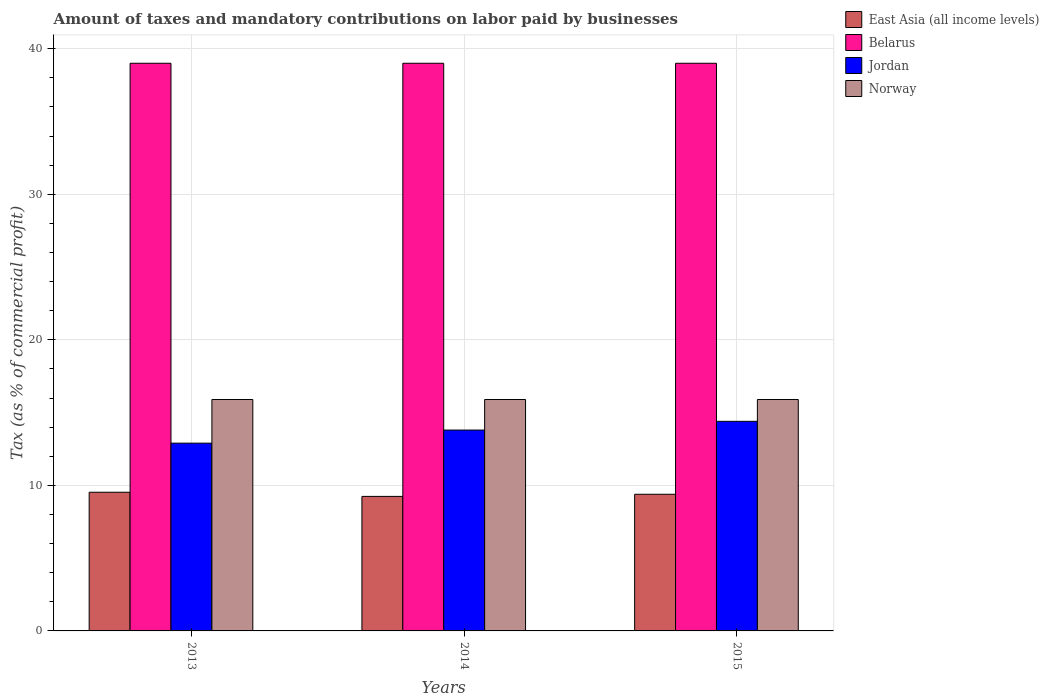How many different coloured bars are there?
Keep it short and to the point. 4. How many groups of bars are there?
Keep it short and to the point. 3. Are the number of bars per tick equal to the number of legend labels?
Provide a short and direct response. Yes. Are the number of bars on each tick of the X-axis equal?
Your answer should be compact. Yes. How many bars are there on the 1st tick from the right?
Give a very brief answer. 4. In how many cases, is the number of bars for a given year not equal to the number of legend labels?
Your response must be concise. 0. What is the percentage of taxes paid by businesses in East Asia (all income levels) in 2014?
Give a very brief answer. 9.24. Across all years, what is the minimum percentage of taxes paid by businesses in Norway?
Offer a very short reply. 15.9. In which year was the percentage of taxes paid by businesses in East Asia (all income levels) maximum?
Your answer should be compact. 2013. What is the total percentage of taxes paid by businesses in Norway in the graph?
Provide a succinct answer. 47.7. What is the difference between the percentage of taxes paid by businesses in East Asia (all income levels) in 2014 and that in 2015?
Your answer should be compact. -0.15. What is the difference between the percentage of taxes paid by businesses in Norway in 2015 and the percentage of taxes paid by businesses in Belarus in 2013?
Give a very brief answer. -23.1. What is the average percentage of taxes paid by businesses in Belarus per year?
Provide a succinct answer. 39. In the year 2014, what is the difference between the percentage of taxes paid by businesses in Norway and percentage of taxes paid by businesses in Jordan?
Your answer should be very brief. 2.1. In how many years, is the percentage of taxes paid by businesses in East Asia (all income levels) greater than 34 %?
Make the answer very short. 0. Is the percentage of taxes paid by businesses in East Asia (all income levels) in 2013 less than that in 2015?
Offer a terse response. No. Is the difference between the percentage of taxes paid by businesses in Norway in 2014 and 2015 greater than the difference between the percentage of taxes paid by businesses in Jordan in 2014 and 2015?
Your answer should be compact. Yes. What is the difference between the highest and the lowest percentage of taxes paid by businesses in East Asia (all income levels)?
Give a very brief answer. 0.29. In how many years, is the percentage of taxes paid by businesses in Belarus greater than the average percentage of taxes paid by businesses in Belarus taken over all years?
Your answer should be very brief. 0. Is the sum of the percentage of taxes paid by businesses in Norway in 2013 and 2015 greater than the maximum percentage of taxes paid by businesses in Jordan across all years?
Your answer should be very brief. Yes. Is it the case that in every year, the sum of the percentage of taxes paid by businesses in Norway and percentage of taxes paid by businesses in Jordan is greater than the sum of percentage of taxes paid by businesses in Belarus and percentage of taxes paid by businesses in East Asia (all income levels)?
Your answer should be compact. Yes. What does the 3rd bar from the left in 2013 represents?
Keep it short and to the point. Jordan. What does the 2nd bar from the right in 2014 represents?
Make the answer very short. Jordan. Is it the case that in every year, the sum of the percentage of taxes paid by businesses in Belarus and percentage of taxes paid by businesses in Jordan is greater than the percentage of taxes paid by businesses in East Asia (all income levels)?
Give a very brief answer. Yes. How many bars are there?
Make the answer very short. 12. How many years are there in the graph?
Offer a very short reply. 3. What is the difference between two consecutive major ticks on the Y-axis?
Provide a succinct answer. 10. Are the values on the major ticks of Y-axis written in scientific E-notation?
Ensure brevity in your answer.  No. Does the graph contain any zero values?
Offer a very short reply. No. Does the graph contain grids?
Provide a short and direct response. Yes. Where does the legend appear in the graph?
Provide a short and direct response. Top right. How many legend labels are there?
Ensure brevity in your answer.  4. What is the title of the graph?
Your response must be concise. Amount of taxes and mandatory contributions on labor paid by businesses. What is the label or title of the Y-axis?
Make the answer very short. Tax (as % of commercial profit). What is the Tax (as % of commercial profit) of East Asia (all income levels) in 2013?
Ensure brevity in your answer.  9.53. What is the Tax (as % of commercial profit) in East Asia (all income levels) in 2014?
Your response must be concise. 9.24. What is the Tax (as % of commercial profit) of Belarus in 2014?
Your answer should be very brief. 39. What is the Tax (as % of commercial profit) in Jordan in 2014?
Ensure brevity in your answer.  13.8. What is the Tax (as % of commercial profit) in East Asia (all income levels) in 2015?
Offer a very short reply. 9.39. What is the Tax (as % of commercial profit) in Belarus in 2015?
Your answer should be very brief. 39. What is the Tax (as % of commercial profit) of Jordan in 2015?
Your answer should be very brief. 14.4. What is the Tax (as % of commercial profit) in Norway in 2015?
Your response must be concise. 15.9. Across all years, what is the maximum Tax (as % of commercial profit) of East Asia (all income levels)?
Your answer should be very brief. 9.53. Across all years, what is the maximum Tax (as % of commercial profit) of Jordan?
Give a very brief answer. 14.4. Across all years, what is the minimum Tax (as % of commercial profit) in East Asia (all income levels)?
Provide a succinct answer. 9.24. Across all years, what is the minimum Tax (as % of commercial profit) in Jordan?
Your answer should be compact. 12.9. Across all years, what is the minimum Tax (as % of commercial profit) of Norway?
Give a very brief answer. 15.9. What is the total Tax (as % of commercial profit) in East Asia (all income levels) in the graph?
Offer a very short reply. 28.16. What is the total Tax (as % of commercial profit) in Belarus in the graph?
Offer a very short reply. 117. What is the total Tax (as % of commercial profit) of Jordan in the graph?
Give a very brief answer. 41.1. What is the total Tax (as % of commercial profit) in Norway in the graph?
Make the answer very short. 47.7. What is the difference between the Tax (as % of commercial profit) in East Asia (all income levels) in 2013 and that in 2014?
Your answer should be compact. 0.29. What is the difference between the Tax (as % of commercial profit) of Belarus in 2013 and that in 2014?
Offer a very short reply. 0. What is the difference between the Tax (as % of commercial profit) in Jordan in 2013 and that in 2014?
Your answer should be very brief. -0.9. What is the difference between the Tax (as % of commercial profit) of East Asia (all income levels) in 2013 and that in 2015?
Your response must be concise. 0.14. What is the difference between the Tax (as % of commercial profit) of Belarus in 2013 and that in 2015?
Provide a succinct answer. 0. What is the difference between the Tax (as % of commercial profit) of East Asia (all income levels) in 2014 and that in 2015?
Ensure brevity in your answer.  -0.15. What is the difference between the Tax (as % of commercial profit) of Belarus in 2014 and that in 2015?
Provide a succinct answer. 0. What is the difference between the Tax (as % of commercial profit) of Jordan in 2014 and that in 2015?
Offer a terse response. -0.6. What is the difference between the Tax (as % of commercial profit) in Norway in 2014 and that in 2015?
Offer a terse response. 0. What is the difference between the Tax (as % of commercial profit) of East Asia (all income levels) in 2013 and the Tax (as % of commercial profit) of Belarus in 2014?
Provide a short and direct response. -29.47. What is the difference between the Tax (as % of commercial profit) of East Asia (all income levels) in 2013 and the Tax (as % of commercial profit) of Jordan in 2014?
Ensure brevity in your answer.  -4.27. What is the difference between the Tax (as % of commercial profit) in East Asia (all income levels) in 2013 and the Tax (as % of commercial profit) in Norway in 2014?
Offer a very short reply. -6.37. What is the difference between the Tax (as % of commercial profit) of Belarus in 2013 and the Tax (as % of commercial profit) of Jordan in 2014?
Your answer should be very brief. 25.2. What is the difference between the Tax (as % of commercial profit) of Belarus in 2013 and the Tax (as % of commercial profit) of Norway in 2014?
Offer a terse response. 23.1. What is the difference between the Tax (as % of commercial profit) of Jordan in 2013 and the Tax (as % of commercial profit) of Norway in 2014?
Make the answer very short. -3. What is the difference between the Tax (as % of commercial profit) in East Asia (all income levels) in 2013 and the Tax (as % of commercial profit) in Belarus in 2015?
Give a very brief answer. -29.47. What is the difference between the Tax (as % of commercial profit) in East Asia (all income levels) in 2013 and the Tax (as % of commercial profit) in Jordan in 2015?
Keep it short and to the point. -4.87. What is the difference between the Tax (as % of commercial profit) in East Asia (all income levels) in 2013 and the Tax (as % of commercial profit) in Norway in 2015?
Give a very brief answer. -6.37. What is the difference between the Tax (as % of commercial profit) of Belarus in 2013 and the Tax (as % of commercial profit) of Jordan in 2015?
Offer a terse response. 24.6. What is the difference between the Tax (as % of commercial profit) in Belarus in 2013 and the Tax (as % of commercial profit) in Norway in 2015?
Make the answer very short. 23.1. What is the difference between the Tax (as % of commercial profit) in Jordan in 2013 and the Tax (as % of commercial profit) in Norway in 2015?
Offer a very short reply. -3. What is the difference between the Tax (as % of commercial profit) of East Asia (all income levels) in 2014 and the Tax (as % of commercial profit) of Belarus in 2015?
Provide a succinct answer. -29.76. What is the difference between the Tax (as % of commercial profit) in East Asia (all income levels) in 2014 and the Tax (as % of commercial profit) in Jordan in 2015?
Your answer should be compact. -5.16. What is the difference between the Tax (as % of commercial profit) in East Asia (all income levels) in 2014 and the Tax (as % of commercial profit) in Norway in 2015?
Ensure brevity in your answer.  -6.66. What is the difference between the Tax (as % of commercial profit) in Belarus in 2014 and the Tax (as % of commercial profit) in Jordan in 2015?
Offer a very short reply. 24.6. What is the difference between the Tax (as % of commercial profit) in Belarus in 2014 and the Tax (as % of commercial profit) in Norway in 2015?
Your response must be concise. 23.1. What is the difference between the Tax (as % of commercial profit) in Jordan in 2014 and the Tax (as % of commercial profit) in Norway in 2015?
Keep it short and to the point. -2.1. What is the average Tax (as % of commercial profit) in East Asia (all income levels) per year?
Give a very brief answer. 9.39. What is the average Tax (as % of commercial profit) of Belarus per year?
Give a very brief answer. 39. What is the average Tax (as % of commercial profit) of Jordan per year?
Offer a terse response. 13.7. In the year 2013, what is the difference between the Tax (as % of commercial profit) in East Asia (all income levels) and Tax (as % of commercial profit) in Belarus?
Your answer should be very brief. -29.47. In the year 2013, what is the difference between the Tax (as % of commercial profit) in East Asia (all income levels) and Tax (as % of commercial profit) in Jordan?
Offer a very short reply. -3.37. In the year 2013, what is the difference between the Tax (as % of commercial profit) of East Asia (all income levels) and Tax (as % of commercial profit) of Norway?
Make the answer very short. -6.37. In the year 2013, what is the difference between the Tax (as % of commercial profit) in Belarus and Tax (as % of commercial profit) in Jordan?
Give a very brief answer. 26.1. In the year 2013, what is the difference between the Tax (as % of commercial profit) in Belarus and Tax (as % of commercial profit) in Norway?
Provide a short and direct response. 23.1. In the year 2013, what is the difference between the Tax (as % of commercial profit) in Jordan and Tax (as % of commercial profit) in Norway?
Ensure brevity in your answer.  -3. In the year 2014, what is the difference between the Tax (as % of commercial profit) of East Asia (all income levels) and Tax (as % of commercial profit) of Belarus?
Keep it short and to the point. -29.76. In the year 2014, what is the difference between the Tax (as % of commercial profit) of East Asia (all income levels) and Tax (as % of commercial profit) of Jordan?
Ensure brevity in your answer.  -4.56. In the year 2014, what is the difference between the Tax (as % of commercial profit) of East Asia (all income levels) and Tax (as % of commercial profit) of Norway?
Keep it short and to the point. -6.66. In the year 2014, what is the difference between the Tax (as % of commercial profit) in Belarus and Tax (as % of commercial profit) in Jordan?
Provide a succinct answer. 25.2. In the year 2014, what is the difference between the Tax (as % of commercial profit) of Belarus and Tax (as % of commercial profit) of Norway?
Make the answer very short. 23.1. In the year 2015, what is the difference between the Tax (as % of commercial profit) of East Asia (all income levels) and Tax (as % of commercial profit) of Belarus?
Your answer should be very brief. -29.61. In the year 2015, what is the difference between the Tax (as % of commercial profit) of East Asia (all income levels) and Tax (as % of commercial profit) of Jordan?
Provide a succinct answer. -5.01. In the year 2015, what is the difference between the Tax (as % of commercial profit) of East Asia (all income levels) and Tax (as % of commercial profit) of Norway?
Make the answer very short. -6.51. In the year 2015, what is the difference between the Tax (as % of commercial profit) of Belarus and Tax (as % of commercial profit) of Jordan?
Your answer should be compact. 24.6. In the year 2015, what is the difference between the Tax (as % of commercial profit) of Belarus and Tax (as % of commercial profit) of Norway?
Ensure brevity in your answer.  23.1. What is the ratio of the Tax (as % of commercial profit) in East Asia (all income levels) in 2013 to that in 2014?
Keep it short and to the point. 1.03. What is the ratio of the Tax (as % of commercial profit) of Belarus in 2013 to that in 2014?
Keep it short and to the point. 1. What is the ratio of the Tax (as % of commercial profit) of Jordan in 2013 to that in 2014?
Offer a very short reply. 0.93. What is the ratio of the Tax (as % of commercial profit) of Norway in 2013 to that in 2014?
Provide a short and direct response. 1. What is the ratio of the Tax (as % of commercial profit) of East Asia (all income levels) in 2013 to that in 2015?
Your answer should be compact. 1.01. What is the ratio of the Tax (as % of commercial profit) in Jordan in 2013 to that in 2015?
Ensure brevity in your answer.  0.9. What is the ratio of the Tax (as % of commercial profit) of Norway in 2013 to that in 2015?
Your answer should be very brief. 1. What is the ratio of the Tax (as % of commercial profit) in East Asia (all income levels) in 2014 to that in 2015?
Ensure brevity in your answer.  0.98. What is the difference between the highest and the second highest Tax (as % of commercial profit) in East Asia (all income levels)?
Give a very brief answer. 0.14. What is the difference between the highest and the second highest Tax (as % of commercial profit) of Belarus?
Keep it short and to the point. 0. What is the difference between the highest and the second highest Tax (as % of commercial profit) in Jordan?
Your answer should be compact. 0.6. What is the difference between the highest and the second highest Tax (as % of commercial profit) of Norway?
Offer a very short reply. 0. What is the difference between the highest and the lowest Tax (as % of commercial profit) of East Asia (all income levels)?
Your answer should be compact. 0.29. What is the difference between the highest and the lowest Tax (as % of commercial profit) of Jordan?
Provide a succinct answer. 1.5. What is the difference between the highest and the lowest Tax (as % of commercial profit) of Norway?
Your answer should be very brief. 0. 